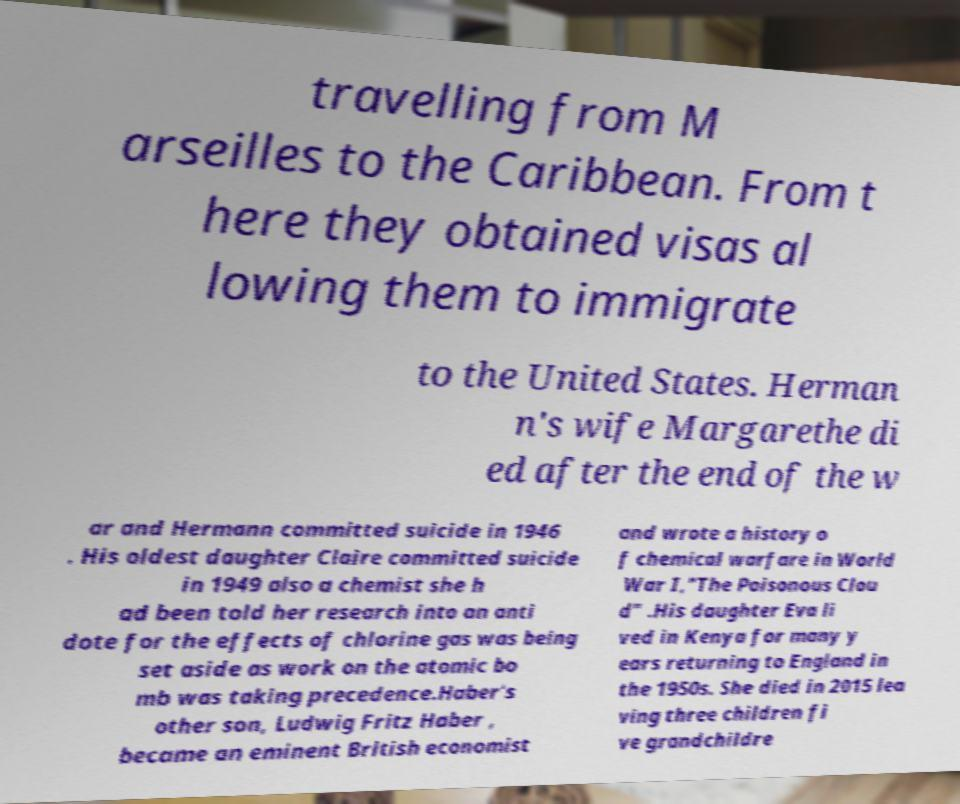Please read and relay the text visible in this image. What does it say? travelling from M arseilles to the Caribbean. From t here they obtained visas al lowing them to immigrate to the United States. Herman n's wife Margarethe di ed after the end of the w ar and Hermann committed suicide in 1946 . His oldest daughter Claire committed suicide in 1949 also a chemist she h ad been told her research into an anti dote for the effects of chlorine gas was being set aside as work on the atomic bo mb was taking precedence.Haber's other son, Ludwig Fritz Haber , became an eminent British economist and wrote a history o f chemical warfare in World War I,"The Poisonous Clou d" .His daughter Eva li ved in Kenya for many y ears returning to England in the 1950s. She died in 2015 lea ving three children fi ve grandchildre 